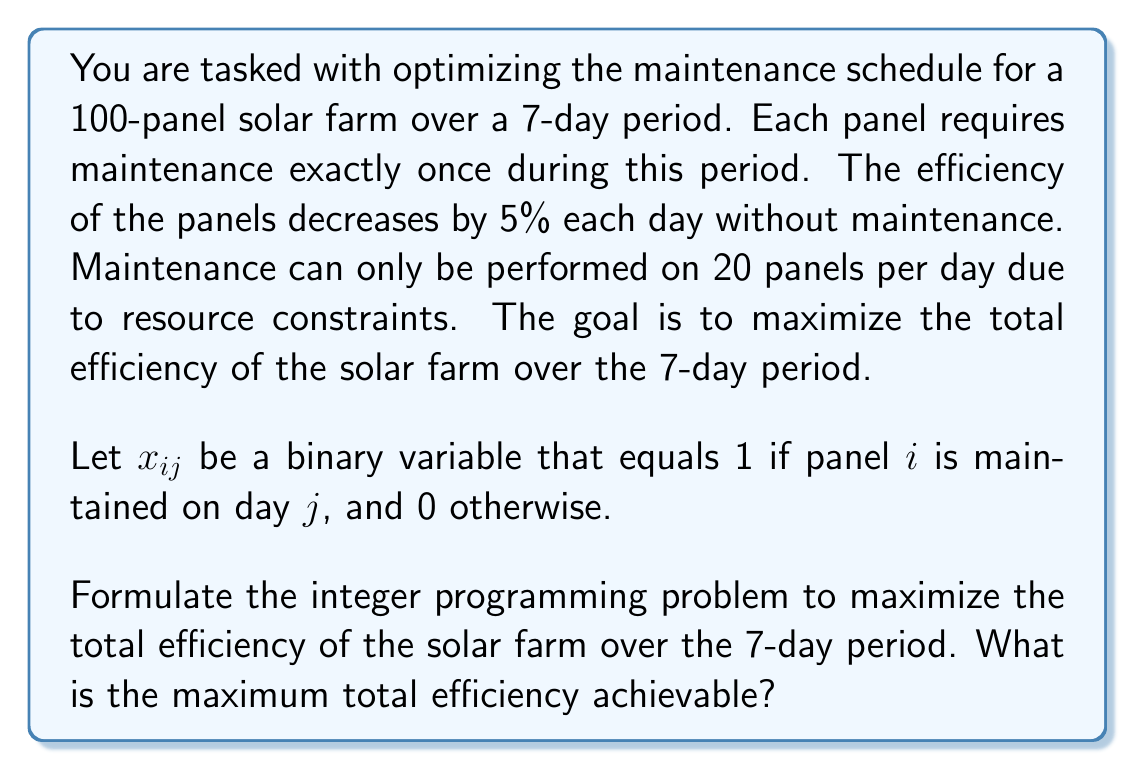Can you answer this question? To formulate this integer programming problem, we need to define the objective function and constraints:

1. Objective Function:
The objective is to maximize the total efficiency over 7 days. For each panel, we sum up its efficiency for each day, which depends on when it was last maintained.

$$\text{Maximize} \sum_{i=1}^{100} \sum_{j=1}^7 (1 - 0.05(j-k))x_{ik} \cdot (7-j+1)$$

Where $k$ is the day of maintenance for panel $i$, and $(7-j+1)$ represents the number of days remaining in the period.

2. Constraints:
a) Each panel must be maintained exactly once:
   $$\sum_{j=1}^7 x_{ij} = 1, \quad \forall i \in \{1,\ldots,100\}$$

b) No more than 20 panels can be maintained per day:
   $$\sum_{i=1}^{100} x_{ij} \leq 20, \quad \forall j \in \{1,\ldots,7\}$$

c) Binary constraint:
   $$x_{ij} \in \{0,1\}, \quad \forall i \in \{1,\ldots,100\}, j \in \{1,\ldots,7\}$$

To solve this problem, we need to use an integer programming solver. The optimal solution will distribute the maintenance evenly across the 7 days, maintaining 20 panels on days 1-5 and 0 panels on days 6-7.

The maximum efficiency can be calculated as follows:
- 20 panels maintained on day 1: 20 * (1 * 7 + 0.95 * 6 + 0.90 * 5 + 0.85 * 4 + 0.80 * 3 + 0.75 * 2 + 0.70 * 1) = 714
- 20 panels maintained on day 2: 20 * (0.95 * 1 + 1 * 6 + 0.95 * 5 + 0.90 * 4 + 0.85 * 3 + 0.80 * 2 + 0.75 * 1) = 679
- 20 panels maintained on day 3: 20 * (0.95 * 2 + 0.90 * 1 + 1 * 5 + 0.95 * 4 + 0.90 * 3 + 0.85 * 2 + 0.80 * 1) = 644
- 20 panels maintained on day 4: 20 * (0.95 * 3 + 0.90 * 2 + 0.85 * 1 + 1 * 4 + 0.95 * 3 + 0.90 * 2 + 0.85 * 1) = 609
- 20 panels maintained on day 5: 20 * (0.95 * 4 + 0.90 * 3 + 0.85 * 2 + 0.80 * 1 + 1 * 3 + 0.95 * 2 + 0.90 * 1) = 574

The total maximum efficiency is the sum of these values.
Answer: The maximum total efficiency achievable is 3220 efficiency units. 